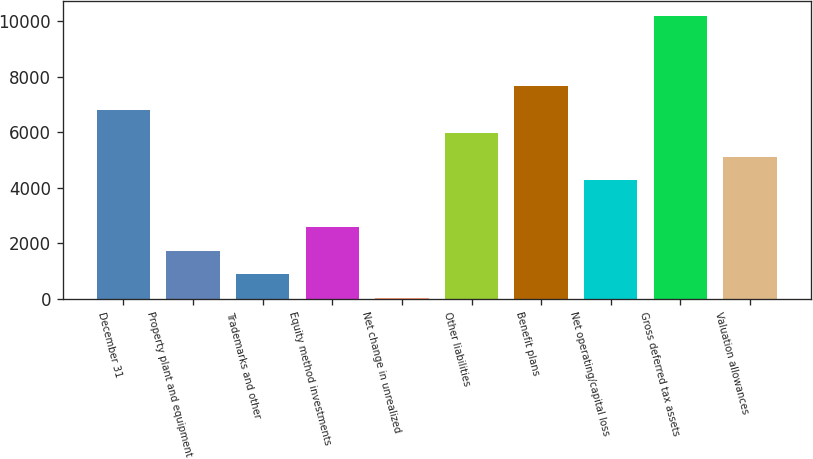<chart> <loc_0><loc_0><loc_500><loc_500><bar_chart><fcel>December 31<fcel>Property plant and equipment<fcel>Trademarks and other<fcel>Equity method investments<fcel>Net change in unrealized<fcel>Other liabilities<fcel>Benefit plans<fcel>Net operating/capital loss<fcel>Gross deferred tax assets<fcel>Valuation allowances<nl><fcel>6818.2<fcel>1736.8<fcel>889.9<fcel>2583.7<fcel>43<fcel>5971.3<fcel>7665.1<fcel>4277.5<fcel>10205.8<fcel>5124.4<nl></chart> 